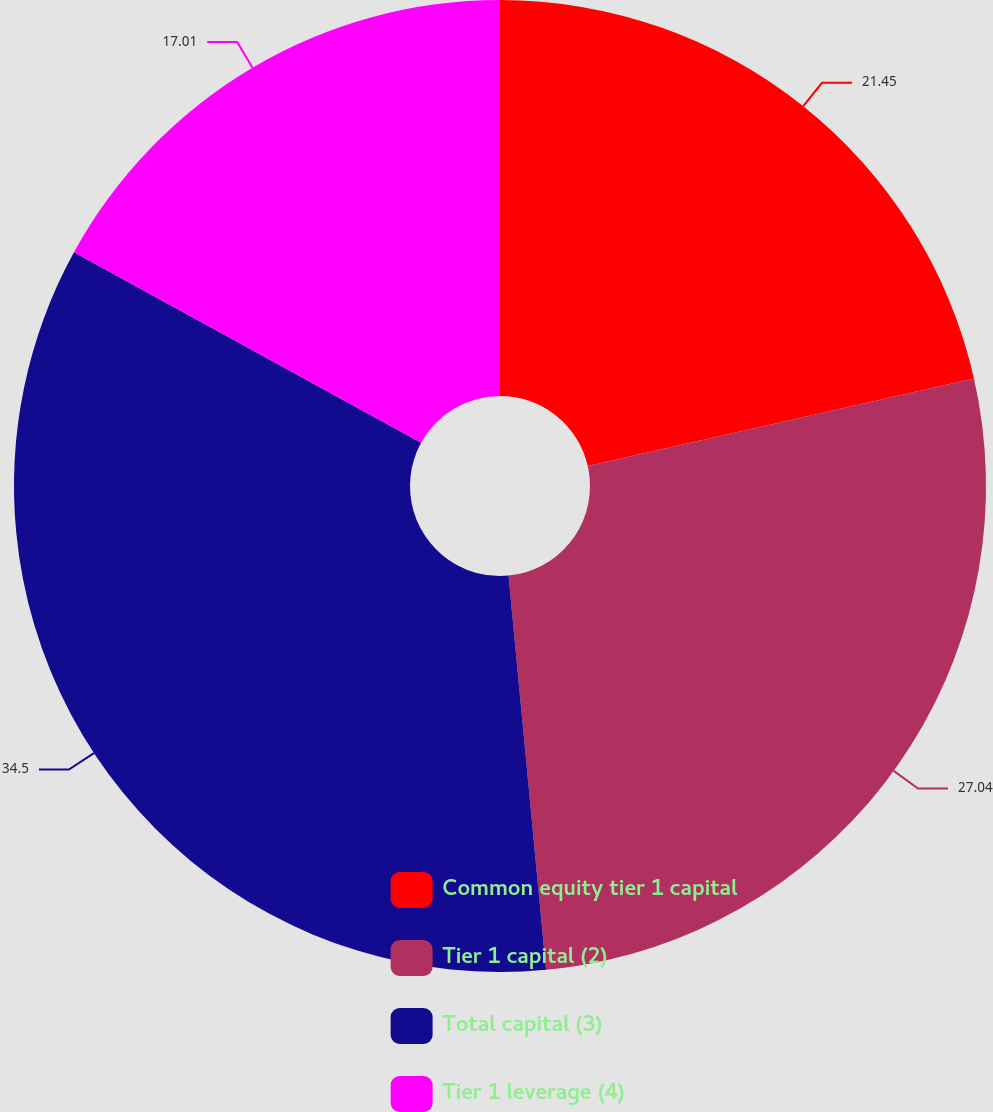Convert chart. <chart><loc_0><loc_0><loc_500><loc_500><pie_chart><fcel>Common equity tier 1 capital<fcel>Tier 1 capital (2)<fcel>Total capital (3)<fcel>Tier 1 leverage (4)<nl><fcel>21.45%<fcel>27.04%<fcel>34.5%<fcel>17.01%<nl></chart> 